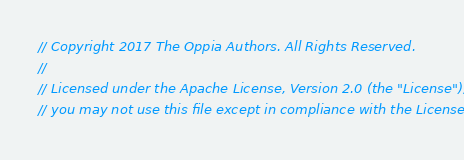Convert code to text. <code><loc_0><loc_0><loc_500><loc_500><_TypeScript_>// Copyright 2017 The Oppia Authors. All Rights Reserved.
//
// Licensed under the Apache License, Version 2.0 (the "License");
// you may not use this file except in compliance with the License.</code> 